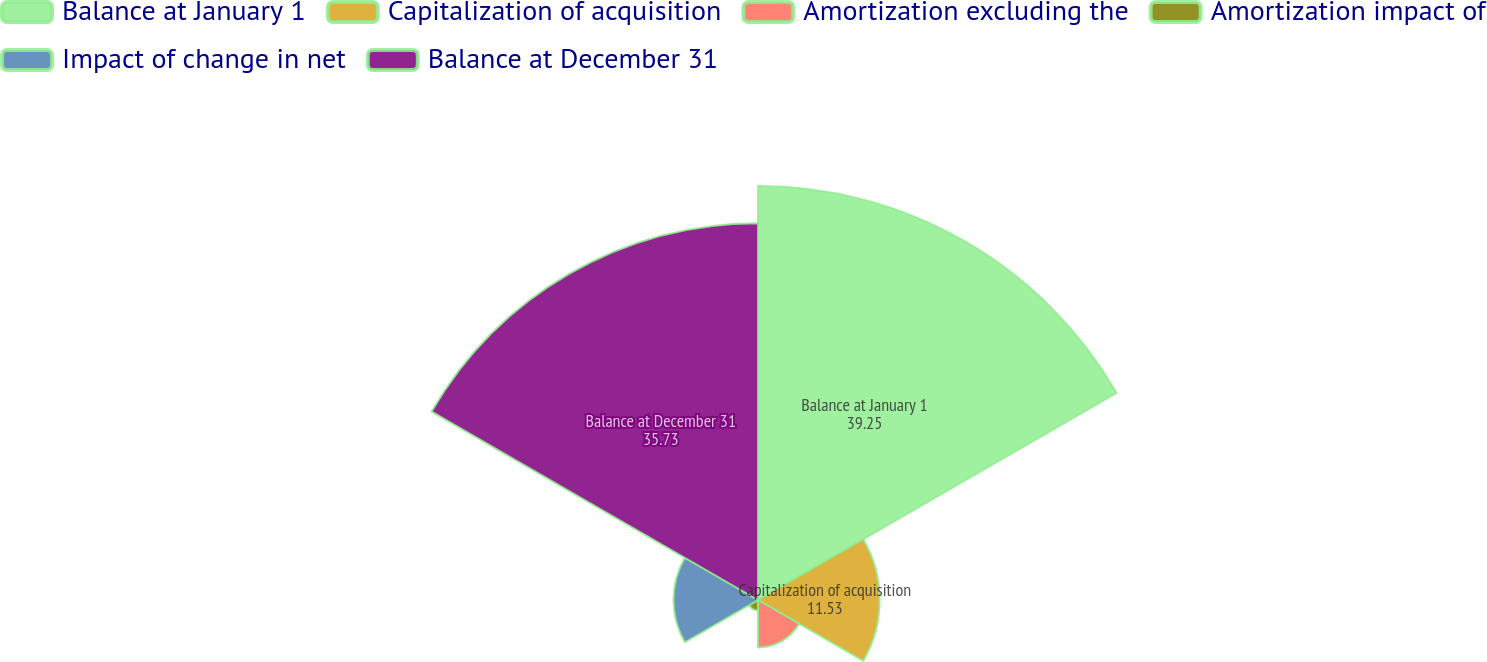Convert chart to OTSL. <chart><loc_0><loc_0><loc_500><loc_500><pie_chart><fcel>Balance at January 1<fcel>Capitalization of acquisition<fcel>Amortization excluding the<fcel>Amortization impact of<fcel>Impact of change in net<fcel>Balance at December 31<nl><fcel>39.25%<fcel>11.53%<fcel>4.5%<fcel>0.98%<fcel>8.01%<fcel>35.73%<nl></chart> 